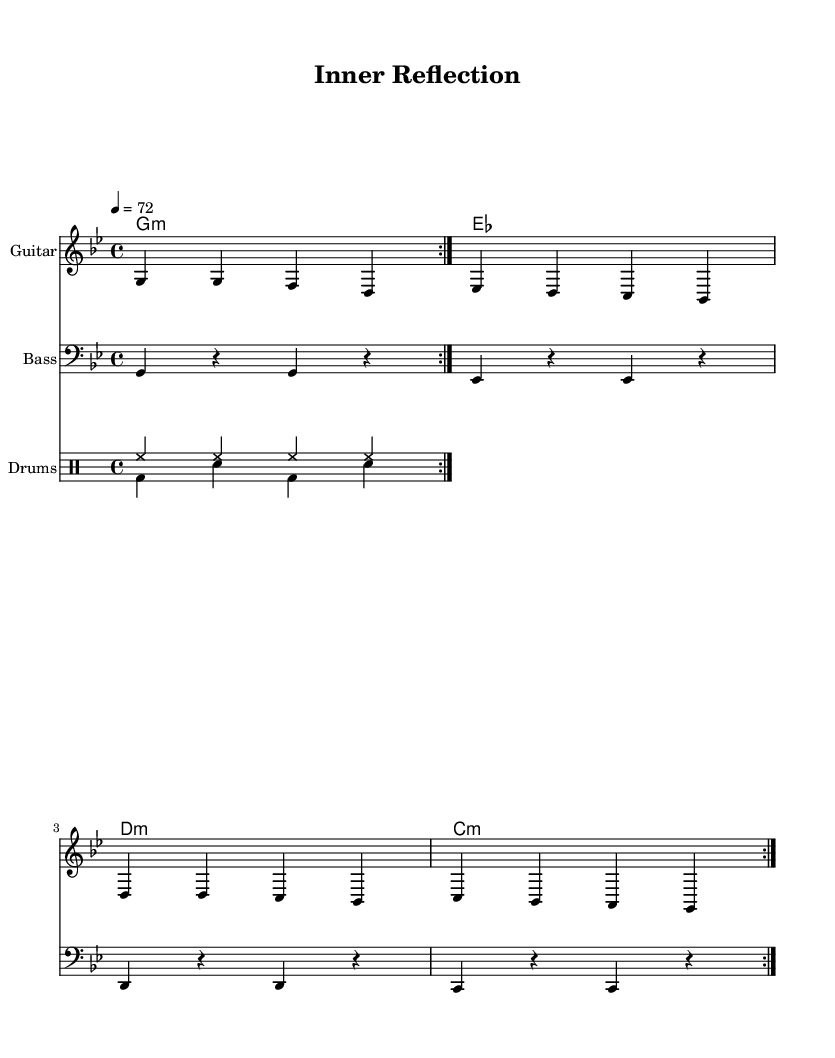What is the key signature of this music? The key signature is G minor, which has two flats (B flat and E flat). This is indicated at the beginning of the staff.
Answer: G minor What is the time signature of this piece? The time signature is 4/4, which means there are four beats in each measure. It is indicated at the beginning of the score.
Answer: 4/4 What is the tempo marking for the music? The tempo marking is quarter note equals 72, indicating a moderate speed for the piece. This is shown at the beginning of the score as '4 = 72'.
Answer: 72 How many times is the guitar section repeated? The guitar section is repeated twice as indicated by the 'volta 2' marking in the music notation for guitar.
Answer: 2 Which instruments are included in this piece? The piece includes guitar, bass, and drums, as indicated by the respective staff labels.
Answer: Guitar, Bass, Drums What type of rhythm does the drum section primarily use? The drum section primarily uses a steady hi-hat pattern and a kick-snare pattern, characteristic of reggae. This can be seen through the repeated measures in each drum staff.
Answer: Steady hi-hat and kick-snare What is the second chord in the progression? The second chord in the chord progression is E flat minor, as listed in the chord names in the score.
Answer: E flat minor 